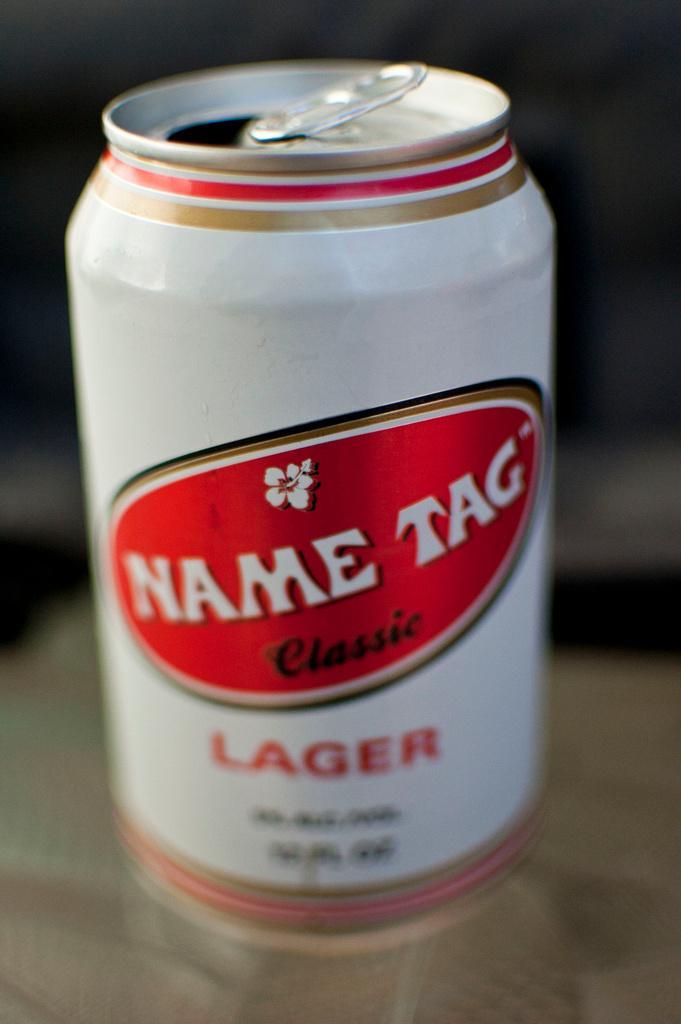How would you summarize this image in a sentence or two? In this image we can color white color tin on which we can see some text, is placed on the surface. This part of the image is blurred. 